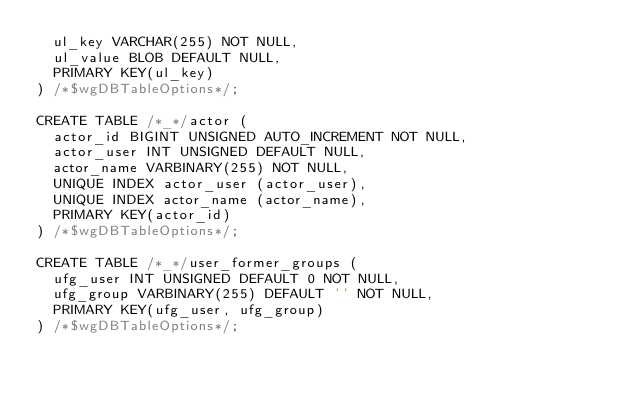Convert code to text. <code><loc_0><loc_0><loc_500><loc_500><_SQL_>  ul_key VARCHAR(255) NOT NULL,
  ul_value BLOB DEFAULT NULL,
  PRIMARY KEY(ul_key)
) /*$wgDBTableOptions*/;

CREATE TABLE /*_*/actor (
  actor_id BIGINT UNSIGNED AUTO_INCREMENT NOT NULL,
  actor_user INT UNSIGNED DEFAULT NULL,
  actor_name VARBINARY(255) NOT NULL,
  UNIQUE INDEX actor_user (actor_user),
  UNIQUE INDEX actor_name (actor_name),
  PRIMARY KEY(actor_id)
) /*$wgDBTableOptions*/;

CREATE TABLE /*_*/user_former_groups (
  ufg_user INT UNSIGNED DEFAULT 0 NOT NULL,
  ufg_group VARBINARY(255) DEFAULT '' NOT NULL,
  PRIMARY KEY(ufg_user, ufg_group)
) /*$wgDBTableOptions*/;
</code> 